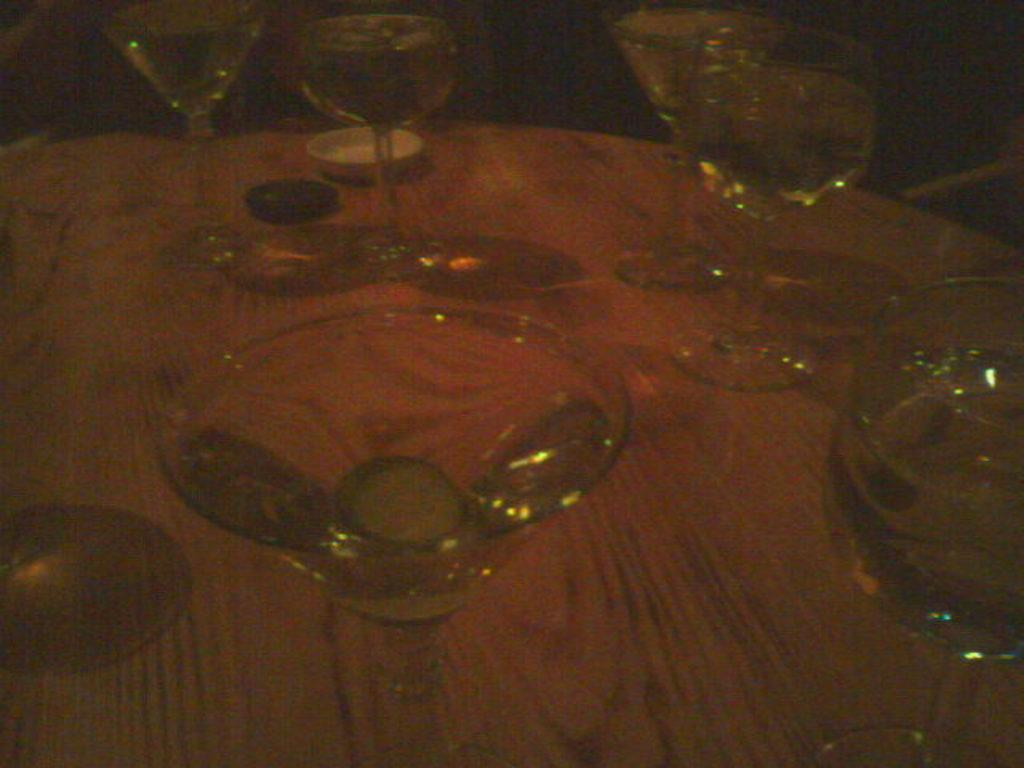What type of objects can be seen in the image? There are glasses in the image. Where are these objects located? The objects are on a wooden surface in the image. What is the scent of the governor in the image? There is no governor or scent mentioned in the image; it only features glasses on a wooden surface. 